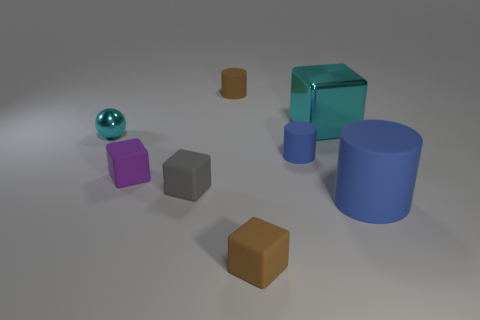Subtract all red blocks. Subtract all yellow balls. How many blocks are left? 4 Add 1 green shiny cylinders. How many objects exist? 9 Subtract all cylinders. How many objects are left? 5 Add 2 small brown cubes. How many small brown cubes are left? 3 Add 6 large gray matte things. How many large gray matte things exist? 6 Subtract 1 purple cubes. How many objects are left? 7 Subtract all small cyan metal cubes. Subtract all gray matte objects. How many objects are left? 7 